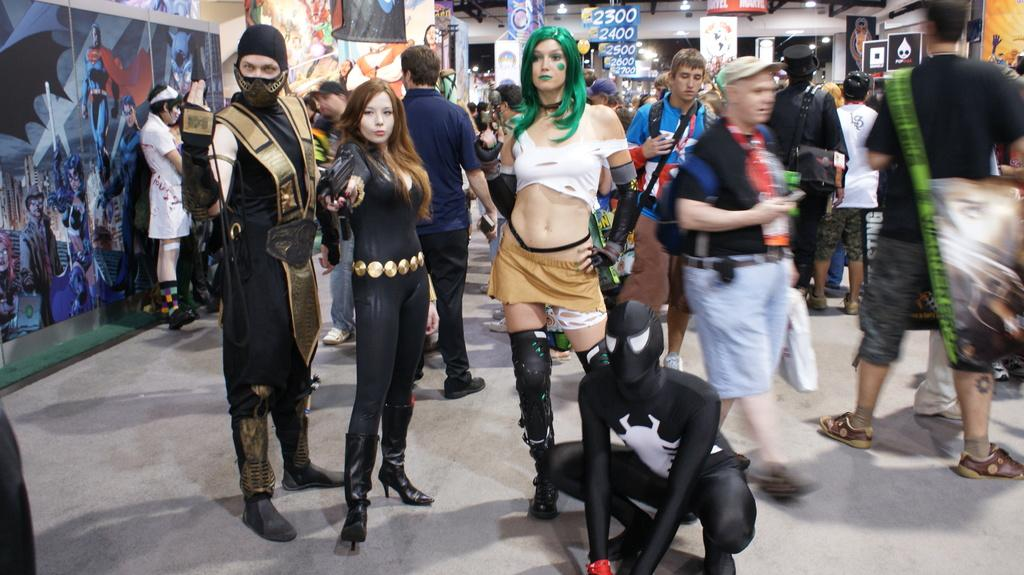How many people can be seen in the image? There are many people in the image. What can be seen in the background of the image? There are posters, banners, and boards in the background of the image. Where is the grandmother sitting in the image? There is no grandmother present in the image. What type of ball can be seen being used by the people in the image? There is no ball present in the image. 